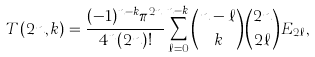Convert formula to latex. <formula><loc_0><loc_0><loc_500><loc_500>T ( 2 n , k ) = \frac { ( - 1 ) ^ { n - k } \pi ^ { 2 n } } { 4 ^ { n } ( 2 n ) ! } \sum _ { \ell = 0 } ^ { n - k } \binom { n - \ell } { k } \binom { 2 n } { 2 \ell } E _ { 2 \ell } ,</formula> 